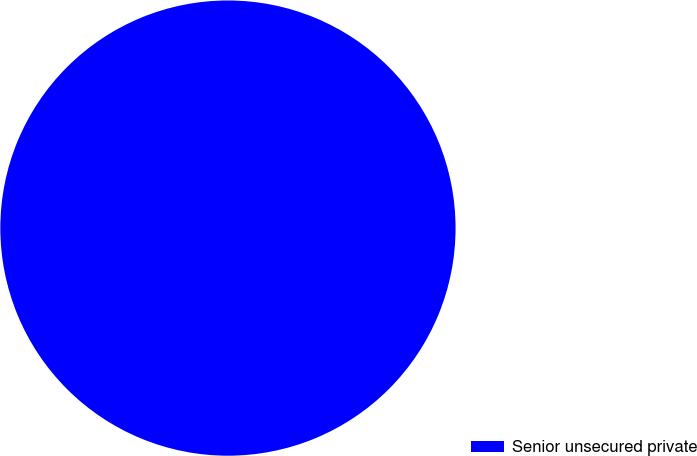Convert chart to OTSL. <chart><loc_0><loc_0><loc_500><loc_500><pie_chart><fcel>Senior unsecured private<nl><fcel>100.0%<nl></chart> 